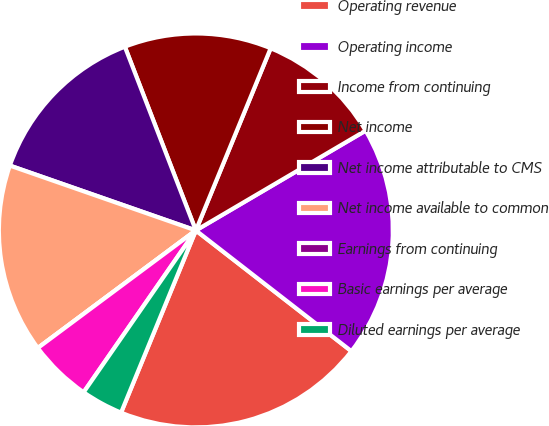<chart> <loc_0><loc_0><loc_500><loc_500><pie_chart><fcel>Operating revenue<fcel>Operating income<fcel>Income from continuing<fcel>Net income<fcel>Net income attributable to CMS<fcel>Net income available to common<fcel>Earnings from continuing<fcel>Basic earnings per average<fcel>Diluted earnings per average<nl><fcel>20.69%<fcel>18.96%<fcel>10.34%<fcel>12.07%<fcel>13.79%<fcel>15.52%<fcel>0.0%<fcel>5.17%<fcel>3.45%<nl></chart> 